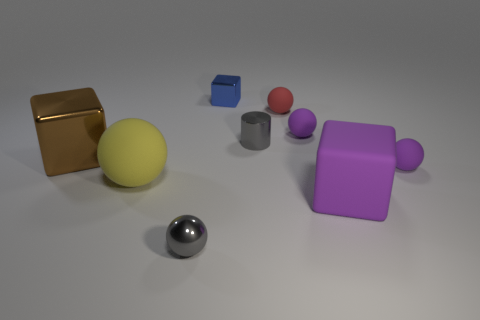Subtract all red spheres. How many spheres are left? 4 Subtract all large yellow rubber spheres. How many spheres are left? 4 Subtract all blue balls. Subtract all blue blocks. How many balls are left? 5 Add 1 red rubber balls. How many objects exist? 10 Subtract all spheres. How many objects are left? 4 Subtract 1 red balls. How many objects are left? 8 Subtract all tiny gray matte blocks. Subtract all small red objects. How many objects are left? 8 Add 4 metallic cylinders. How many metallic cylinders are left? 5 Add 9 cyan balls. How many cyan balls exist? 9 